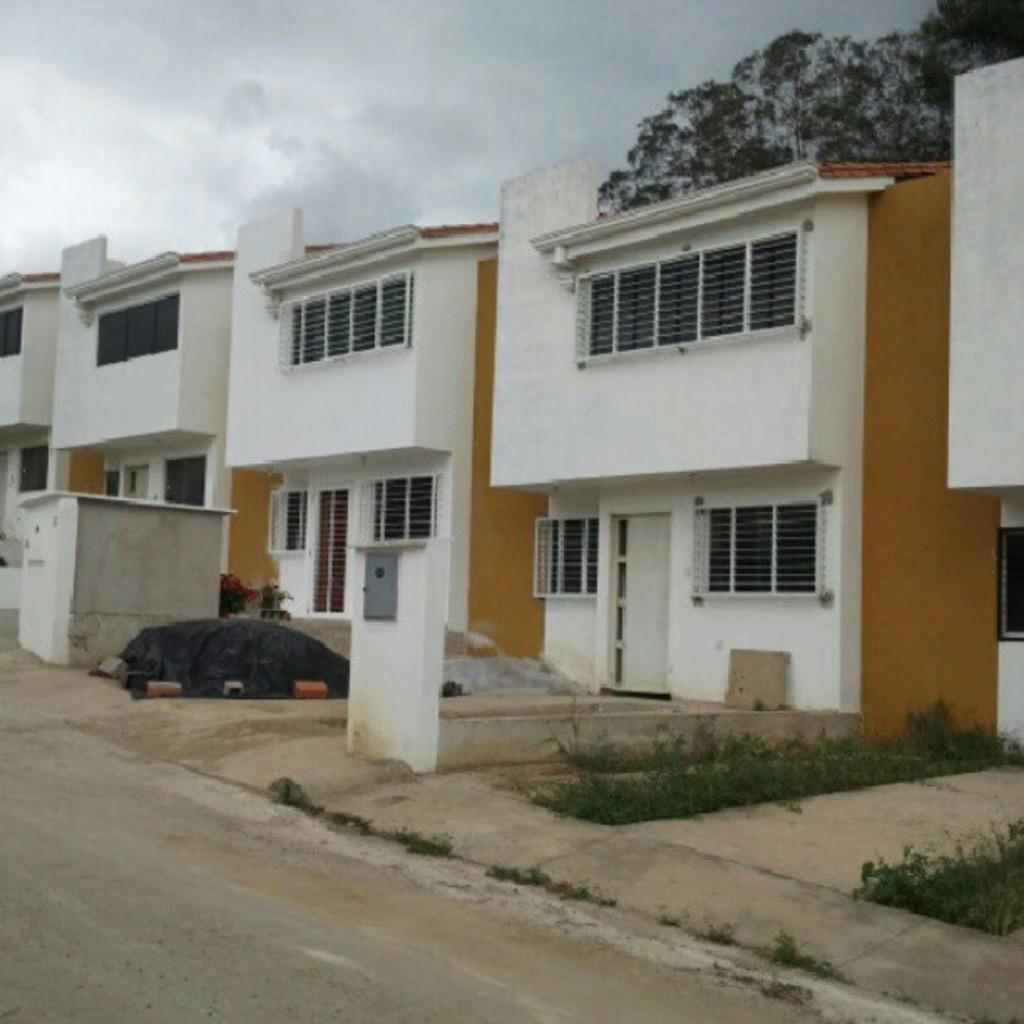What type of structures can be seen in the image? There are houses in the image. What are some features of the houses? The houses have walls, doors, windows, and grills. Are there any other structures in the image besides the houses? Yes, there is a shed in the image. What architectural elements can be seen in the image? There are pillars in the image. What type of vegetation is present in the image? There are plants in the image. What is the landscape like in the image? There is a road in the image, and a tree is visible in the background. What can be seen in the sky in the image? The sky is visible in the background of the image. Where can the fish be found swimming in the image? There are no fish present in the image. What is the stem used for in the image? There is no stem present in the image. 